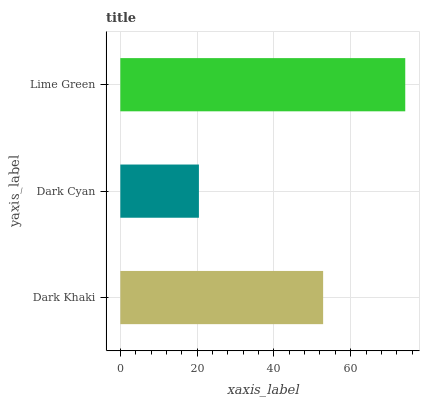Is Dark Cyan the minimum?
Answer yes or no. Yes. Is Lime Green the maximum?
Answer yes or no. Yes. Is Lime Green the minimum?
Answer yes or no. No. Is Dark Cyan the maximum?
Answer yes or no. No. Is Lime Green greater than Dark Cyan?
Answer yes or no. Yes. Is Dark Cyan less than Lime Green?
Answer yes or no. Yes. Is Dark Cyan greater than Lime Green?
Answer yes or no. No. Is Lime Green less than Dark Cyan?
Answer yes or no. No. Is Dark Khaki the high median?
Answer yes or no. Yes. Is Dark Khaki the low median?
Answer yes or no. Yes. Is Dark Cyan the high median?
Answer yes or no. No. Is Lime Green the low median?
Answer yes or no. No. 